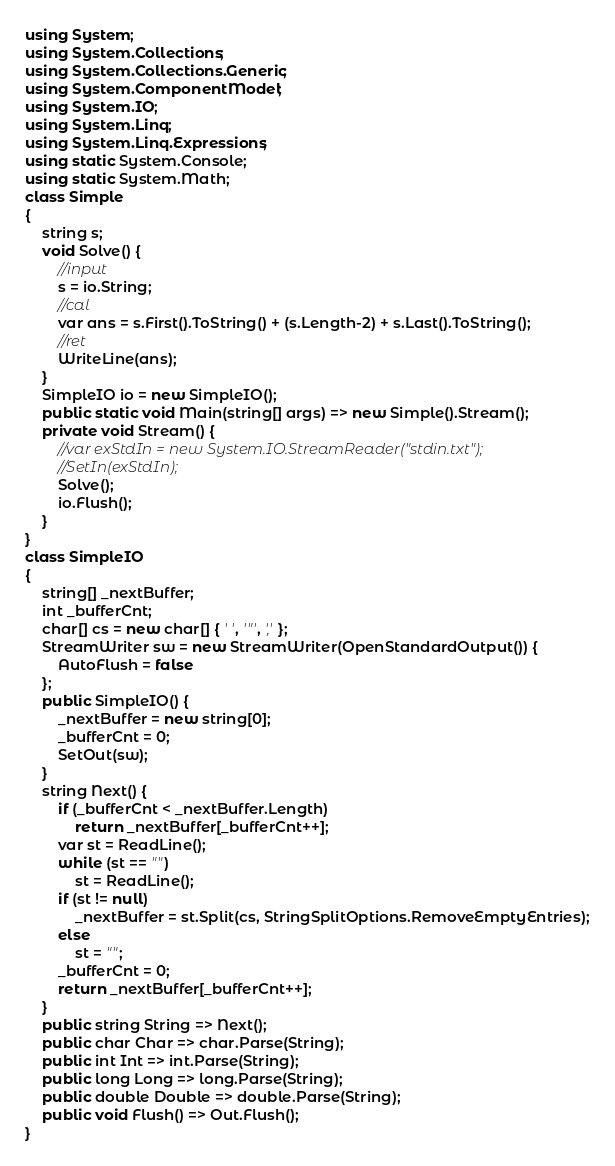Convert code to text. <code><loc_0><loc_0><loc_500><loc_500><_C#_>using System;
using System.Collections;
using System.Collections.Generic;
using System.ComponentModel;
using System.IO;
using System.Linq;
using System.Linq.Expressions;
using static System.Console;
using static System.Math;
class Simple
{
    string s;
    void Solve() {
        //input
        s = io.String;
        //cal
        var ans = s.First().ToString() + (s.Length-2) + s.Last().ToString();
        //ret
        WriteLine(ans);
    }
    SimpleIO io = new SimpleIO();
    public static void Main(string[] args) => new Simple().Stream();
    private void Stream() {
        //var exStdIn = new System.IO.StreamReader("stdin.txt");
        //SetIn(exStdIn);
        Solve();
        io.Flush();
    }
}
class SimpleIO
{
    string[] _nextBuffer;
    int _bufferCnt;
    char[] cs = new char[] { ' ', '"', ',' };
    StreamWriter sw = new StreamWriter(OpenStandardOutput()) {
        AutoFlush = false
    };
    public SimpleIO() {
        _nextBuffer = new string[0];
        _bufferCnt = 0;
        SetOut(sw);
    }
    string Next() {
        if (_bufferCnt < _nextBuffer.Length)
            return _nextBuffer[_bufferCnt++];
        var st = ReadLine();
        while (st == "")
            st = ReadLine();
        if (st != null)
            _nextBuffer = st.Split(cs, StringSplitOptions.RemoveEmptyEntries);
        else
            st = "";
        _bufferCnt = 0;
        return _nextBuffer[_bufferCnt++];
    }
    public string String => Next();
    public char Char => char.Parse(String);
    public int Int => int.Parse(String);
    public long Long => long.Parse(String);
    public double Double => double.Parse(String);
    public void Flush() => Out.Flush();
}
</code> 